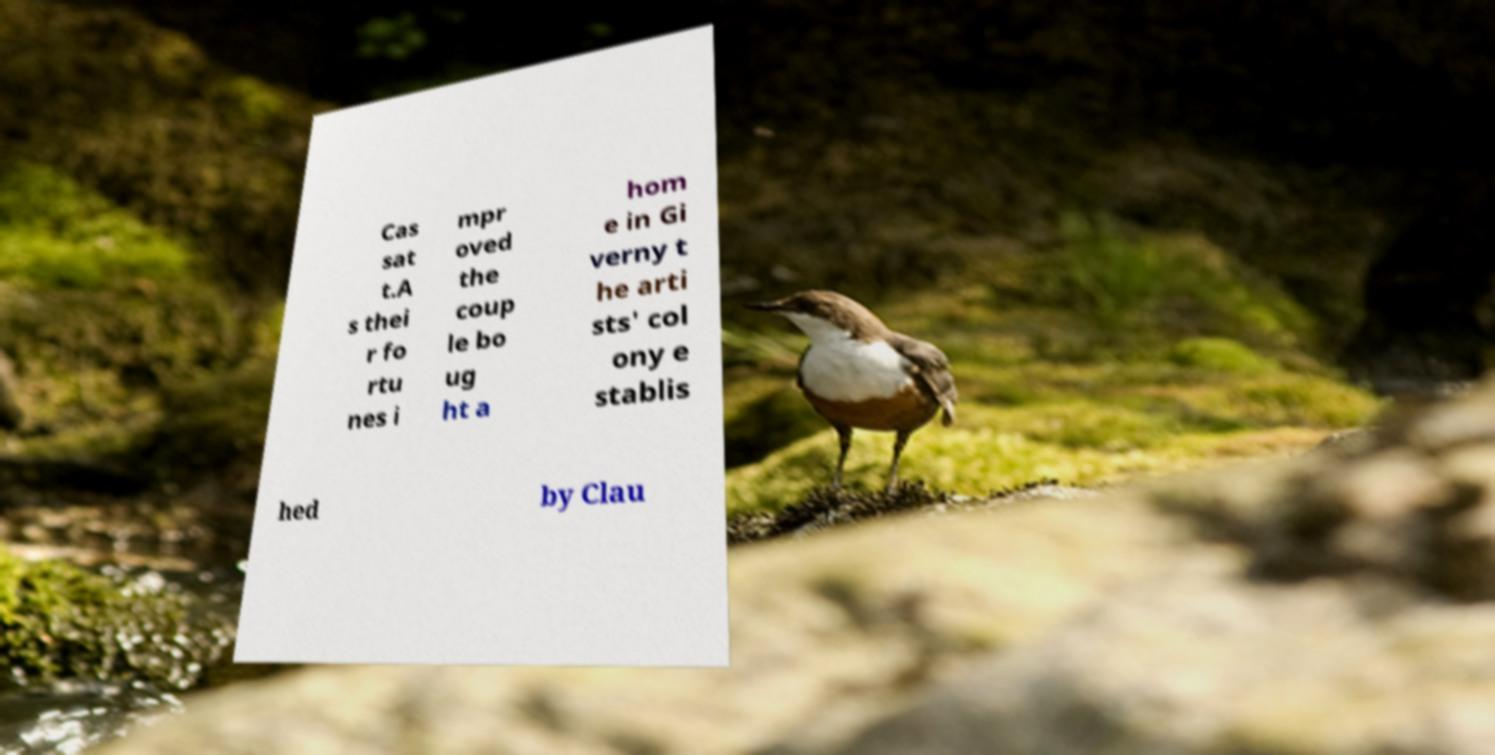Can you accurately transcribe the text from the provided image for me? Cas sat t.A s thei r fo rtu nes i mpr oved the coup le bo ug ht a hom e in Gi verny t he arti sts' col ony e stablis hed by Clau 